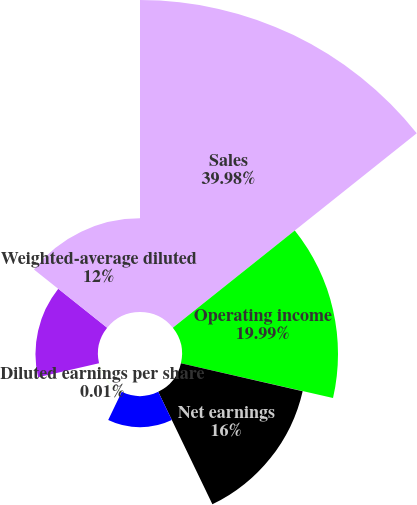Convert chart to OTSL. <chart><loc_0><loc_0><loc_500><loc_500><pie_chart><fcel>Sales<fcel>Operating income<fcel>Net earnings<fcel>Basic earnings per share<fcel>Diluted earnings per share<fcel>Weighted-average common shares<fcel>Weighted-average diluted<nl><fcel>39.98%<fcel>19.99%<fcel>16.0%<fcel>4.01%<fcel>0.01%<fcel>8.01%<fcel>12.0%<nl></chart> 